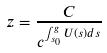<formula> <loc_0><loc_0><loc_500><loc_500>z = \frac { C } { c ^ { \int _ { s _ { 0 } } ^ { g } U ( s ) d s } }</formula> 